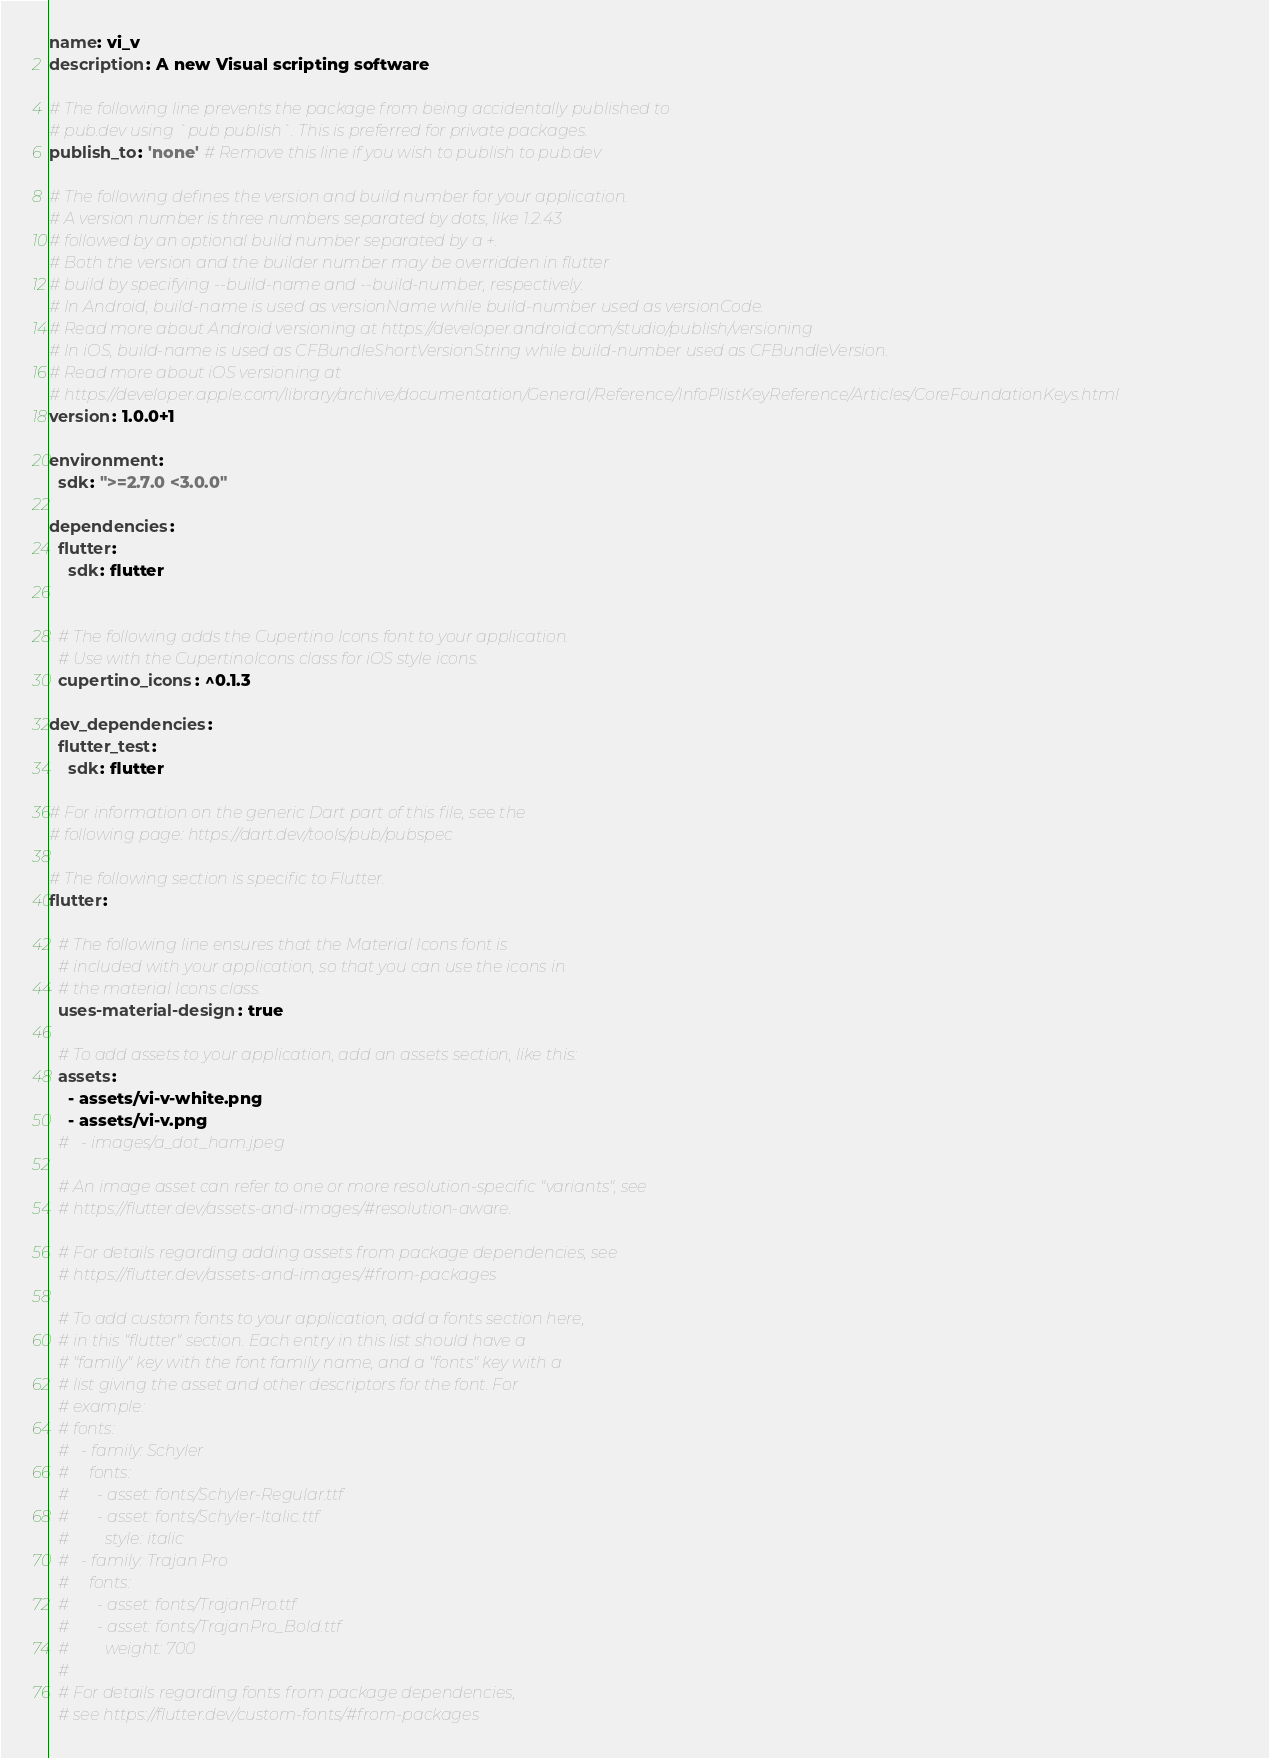Convert code to text. <code><loc_0><loc_0><loc_500><loc_500><_YAML_>name: vi_v
description: A new Visual scripting software

# The following line prevents the package from being accidentally published to
# pub.dev using `pub publish`. This is preferred for private packages.
publish_to: 'none' # Remove this line if you wish to publish to pub.dev

# The following defines the version and build number for your application.
# A version number is three numbers separated by dots, like 1.2.43
# followed by an optional build number separated by a +.
# Both the version and the builder number may be overridden in flutter
# build by specifying --build-name and --build-number, respectively.
# In Android, build-name is used as versionName while build-number used as versionCode.
# Read more about Android versioning at https://developer.android.com/studio/publish/versioning
# In iOS, build-name is used as CFBundleShortVersionString while build-number used as CFBundleVersion.
# Read more about iOS versioning at
# https://developer.apple.com/library/archive/documentation/General/Reference/InfoPlistKeyReference/Articles/CoreFoundationKeys.html
version: 1.0.0+1

environment:
  sdk: ">=2.7.0 <3.0.0"

dependencies:
  flutter:
    sdk: flutter


  # The following adds the Cupertino Icons font to your application.
  # Use with the CupertinoIcons class for iOS style icons.
  cupertino_icons: ^0.1.3

dev_dependencies:
  flutter_test:
    sdk: flutter

# For information on the generic Dart part of this file, see the
# following page: https://dart.dev/tools/pub/pubspec

# The following section is specific to Flutter.
flutter:

  # The following line ensures that the Material Icons font is
  # included with your application, so that you can use the icons in
  # the material Icons class.
  uses-material-design: true

  # To add assets to your application, add an assets section, like this:
  assets:
    - assets/vi-v-white.png
    - assets/vi-v.png
  #   - images/a_dot_ham.jpeg

  # An image asset can refer to one or more resolution-specific "variants", see
  # https://flutter.dev/assets-and-images/#resolution-aware.

  # For details regarding adding assets from package dependencies, see
  # https://flutter.dev/assets-and-images/#from-packages

  # To add custom fonts to your application, add a fonts section here,
  # in this "flutter" section. Each entry in this list should have a
  # "family" key with the font family name, and a "fonts" key with a
  # list giving the asset and other descriptors for the font. For
  # example:
  # fonts:
  #   - family: Schyler
  #     fonts:
  #       - asset: fonts/Schyler-Regular.ttf
  #       - asset: fonts/Schyler-Italic.ttf
  #         style: italic
  #   - family: Trajan Pro
  #     fonts:
  #       - asset: fonts/TrajanPro.ttf
  #       - asset: fonts/TrajanPro_Bold.ttf
  #         weight: 700
  #
  # For details regarding fonts from package dependencies,
  # see https://flutter.dev/custom-fonts/#from-packages
</code> 